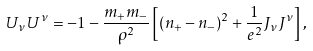<formula> <loc_0><loc_0><loc_500><loc_500>U _ { \nu } U ^ { \nu } = - 1 - \frac { m _ { + } m _ { - } } { \rho ^ { 2 } } \left [ ( n _ { + } - n _ { - } ) ^ { 2 } + \frac { 1 } { e ^ { 2 } } J _ { \nu } J ^ { \nu } \right ] ,</formula> 